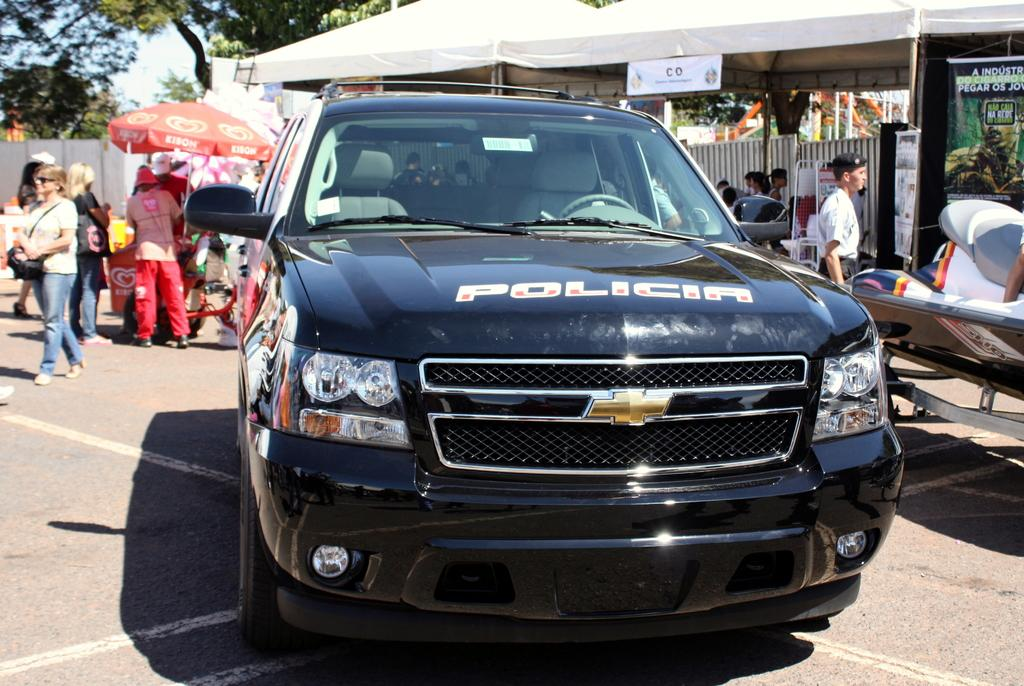What is the main subject in the center of the image? There is a black color car in the center of the image. Where are the people located in the image? There are people on both the right and left sides of the image. What can be seen at the top side of the image? There are trees at the top side of the image. What type of wrench is being used by the passenger in the car? There is no wrench present in the image, and no passengers are mentioned in the provided facts. 